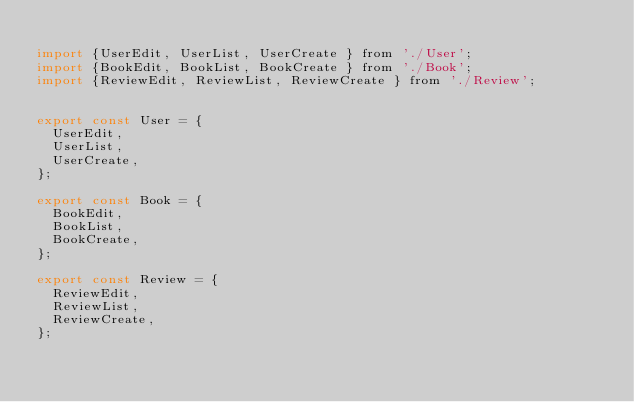<code> <loc_0><loc_0><loc_500><loc_500><_JavaScript_>
import {UserEdit, UserList, UserCreate } from './User';
import {BookEdit, BookList, BookCreate } from './Book';
import {ReviewEdit, ReviewList, ReviewCreate } from './Review';


export const User = {
  UserEdit,
  UserList,
  UserCreate,
};

export const Book = {
  BookEdit,
  BookList,
  BookCreate,
};

export const Review = {
  ReviewEdit,
  ReviewList,
  ReviewCreate,
};
</code> 